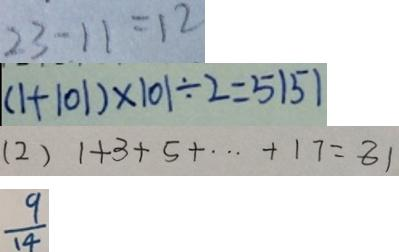<formula> <loc_0><loc_0><loc_500><loc_500>2 3 - 1 1 = 1 2 
 ( 1 + 1 0 1 ) \times 1 0 1 \div 2 = 5 1 5 1 
 ( 2 ) 1 + 3 + 5 + \cdots + 1 7 = 8 1 
 \frac { 9 } { 1 4 }</formula> 